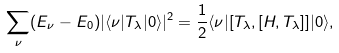<formula> <loc_0><loc_0><loc_500><loc_500>\sum _ { \nu } ( E _ { \nu } - E _ { 0 } ) | \langle \nu | T _ { \lambda } | 0 \rangle | ^ { 2 } = \frac { 1 } { 2 } \langle \nu | [ T _ { \lambda } , [ H , T _ { \lambda } ] ] | 0 \rangle ,</formula> 